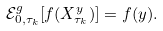Convert formula to latex. <formula><loc_0><loc_0><loc_500><loc_500>\mathcal { E } ^ { g } _ { 0 , \tau _ { k } } [ f ( X ^ { y } _ { \tau _ { k } } ) ] = f ( y ) .</formula> 